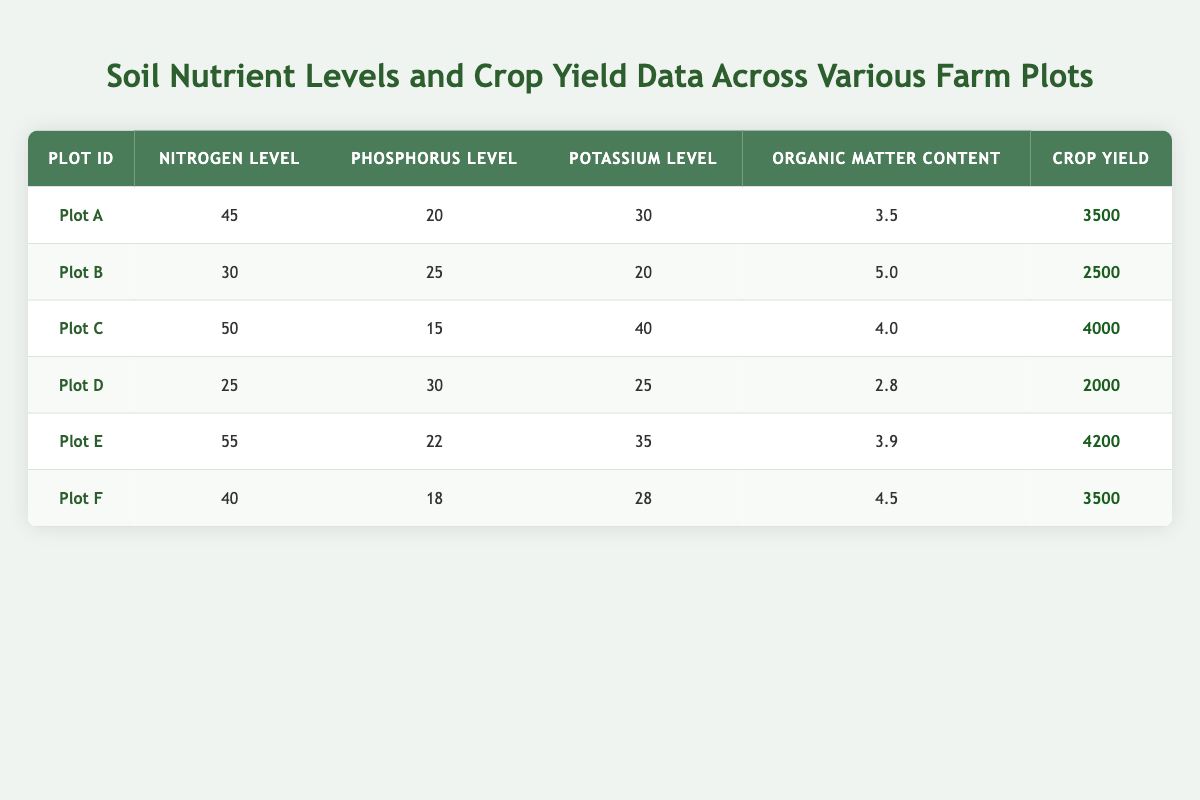What is the crop yield of Plot C? The crop yield for Plot C is directly listed in the table under the "Crop Yield" column for that plot, which shows 4000.
Answer: 4000 What are the nitrogen levels for the plots that have a crop yield above 3500? Reviewing the crop yields, Plot A (3500) and Plot F (3500) don't exceed 3500, so the relevant plots are Plot C (4000) and Plot E (4200). Their nitrogen levels are 50 and 55 respectively.
Answer: 50 and 55 Is the phosphorus level in Plot D higher than in Plot B? The phosphorus level for Plot D is 30 and for Plot B it is 25. Since 30 is greater than 25, the statement is true.
Answer: Yes What is the average organic matter content across all plots? Summing the organic matter contents: 3.5 + 5.0 + 4.0 + 2.8 + 3.9 + 4.5 = 24.7. There are 6 plots, so the average is 24.7 / 6 = 4.1167, which can be rounded to 4.12.
Answer: 4.12 Which plot has the maximum potassium level and what is that level? Reviewing the potassium levels in the table, Plot C has the highest level at 40, compared to 35 in Plot E, which is the next highest, confirming that Plot C is the highest.
Answer: 40 What is the difference in crop yield between Plot E and Plot D? The crop yield for Plot E is 4200 and for Plot D is 2000. To find the difference, subtract Plot D's yield from Plot E's: 4200 - 2000 = 2200.
Answer: 2200 Are nitrogen levels in Plot A and Plot F equal? Checking the nitrogen levels, Plot A has 45 and Plot F has 40. Since 45 is not equal to 40, the answer is no.
Answer: No Which plot has the second highest crop yield, and what is that yield? The crop yields are: Plot E (4200), Plot C (4000), Plot A (3500), Plot F (3500), Plot B (2500), and Plot D (2000). The second highest is Plot C with a yield of 4000.
Answer: Plot C, 4000 